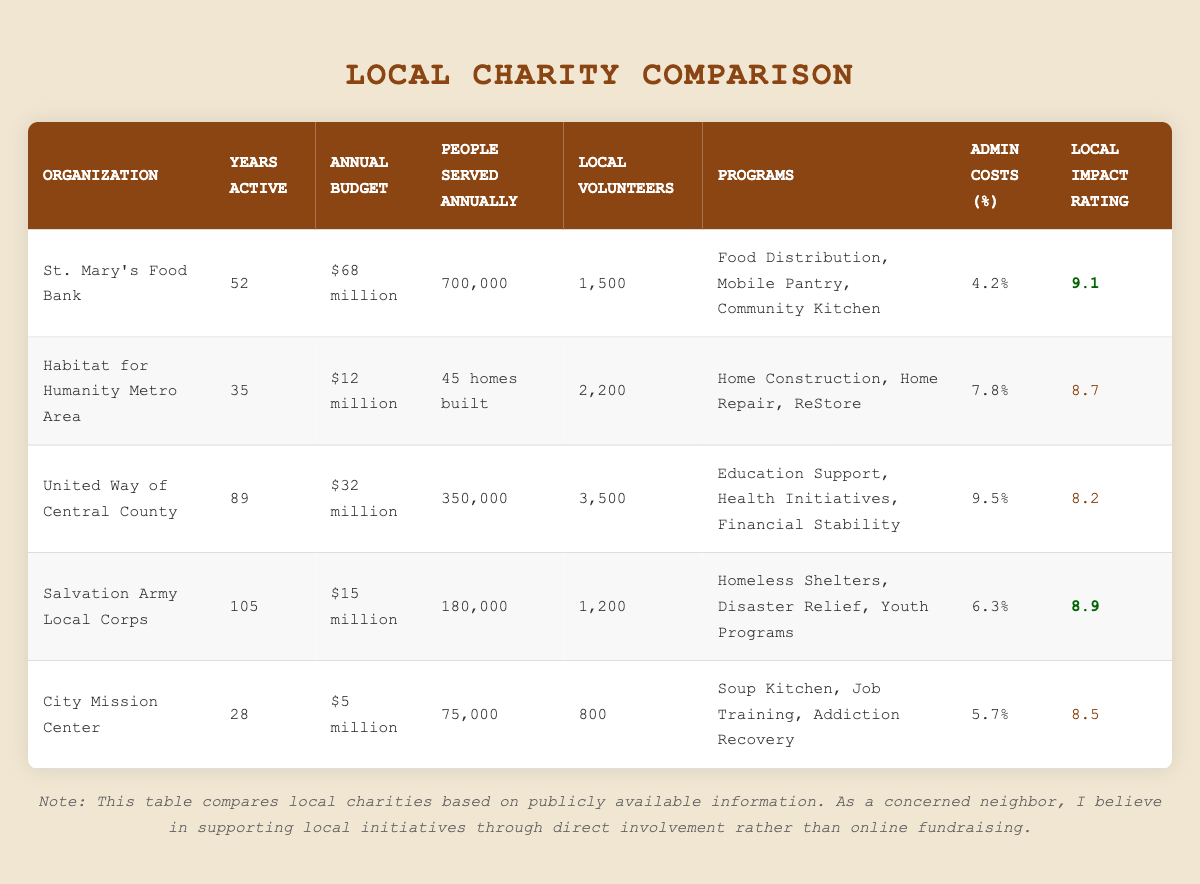What is the annual budget of St. Mary's Food Bank? The table lists the annual budget of St. Mary's Food Bank as $68 million.
Answer: $68 million How many people does United Way of Central County serve annually? According to the table, United Way of Central County serves 350,000 people each year.
Answer: 350,000 Which organization has the highest local impact rating? A quick review of the local impact ratings shows that St. Mary's Food Bank has the highest rating of 9.1.
Answer: St. Mary's Food Bank What is the average percentage of administrative costs for all organizations? To find the average, we sum the administrative costs: 4.2 + 7.8 + 9.5 + 6.3 + 5.7 = 33.5. There are 5 organizations, so the average is 33.5/5 = 6.7.
Answer: 6.7% Is the annual budget of City Mission Center greater than $10 million? The table shows that the annual budget of City Mission Center is $5 million, which is less than $10 million.
Answer: No How many homes does Habitat for Humanity Metro Area build annually compared to St. Mary's Food Bank's services? Habitat for Humanity Metro Area builds 45 homes annually, while St. Mary's Food Bank serves 700,000 people. This shows St. Mary's Food Bank serves significantly more people than Habitat for Humanity builds homes.
Answer: St. Mary's Food Bank serves 700,000 people; Habitat builds 45 homes Which organization has more local volunteers, United Way of Central County or Salvation Army Local Corps? United Way of Central County has 3,500 local volunteers, whereas Salvation Army Local Corps has 1,200 volunteers. Thus, United Way has more volunteers.
Answer: United Way of Central County What is the difference in local impact rating between City Mission Center and Salvation Army Local Corps? City Mission Center has an impact rating of 8.5, and Salvation Army Local Corps has a rating of 8.9. The difference is 8.9 - 8.5 = 0.4.
Answer: 0.4 Which organization serves the least number of people annually? The table indicates that City Mission Center serves the least with 75,000 people annually.
Answer: City Mission Center 